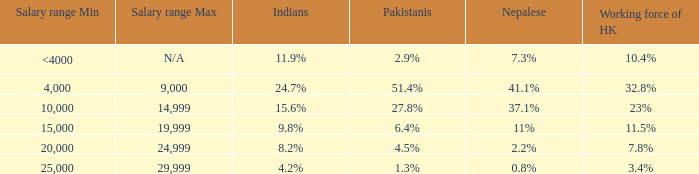If the working force of HK is 10.4%, what is the salary range? <4000. 